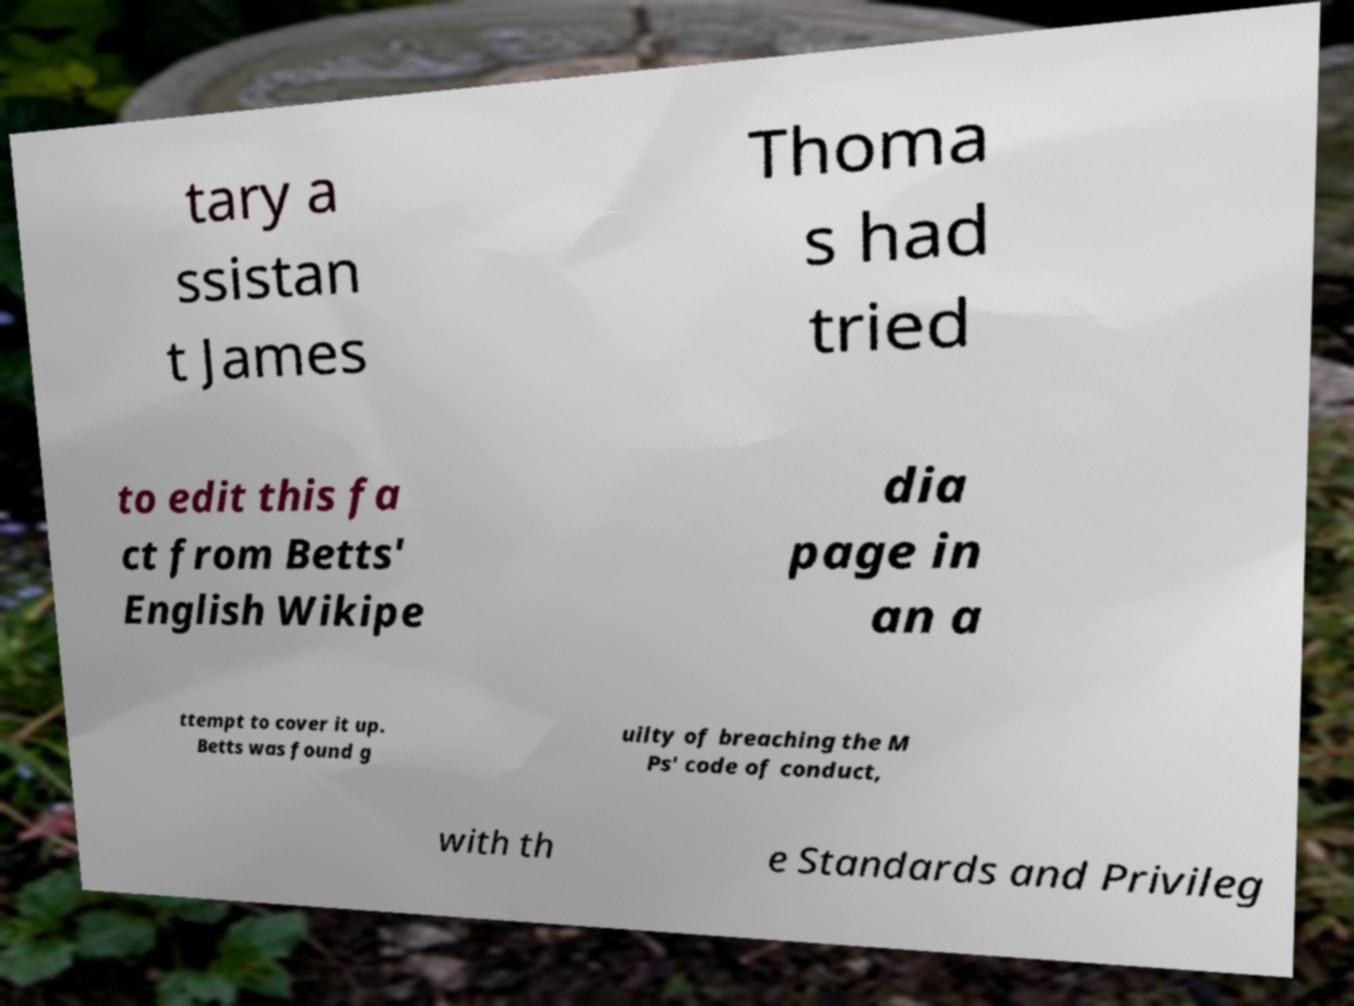Can you accurately transcribe the text from the provided image for me? tary a ssistan t James Thoma s had tried to edit this fa ct from Betts' English Wikipe dia page in an a ttempt to cover it up. Betts was found g uilty of breaching the M Ps' code of conduct, with th e Standards and Privileg 